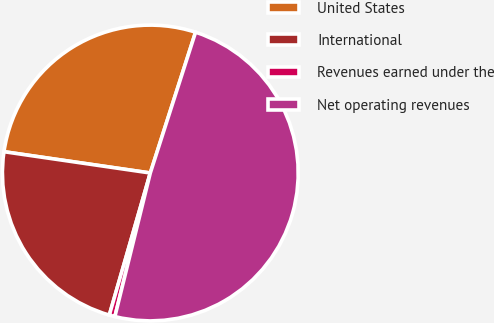Convert chart to OTSL. <chart><loc_0><loc_0><loc_500><loc_500><pie_chart><fcel>United States<fcel>International<fcel>Revenues earned under the<fcel>Net operating revenues<nl><fcel>27.65%<fcel>22.83%<fcel>0.62%<fcel>48.9%<nl></chart> 